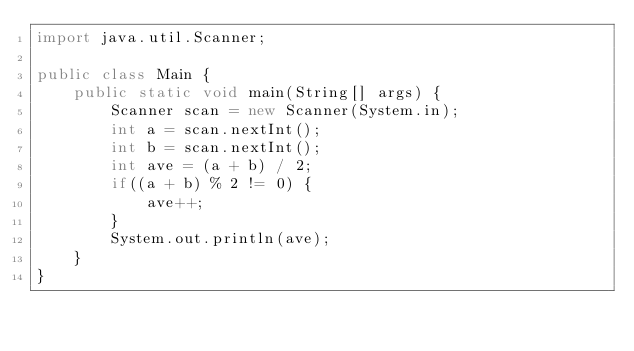<code> <loc_0><loc_0><loc_500><loc_500><_Java_>import java.util.Scanner;

public class Main {
	public static void main(String[] args) {
		Scanner scan = new Scanner(System.in);
		int a = scan.nextInt();
		int b = scan.nextInt();
		int ave = (a + b) / 2;
		if((a + b) % 2 != 0) {
			ave++;
		}
		System.out.println(ave);
	}
}</code> 